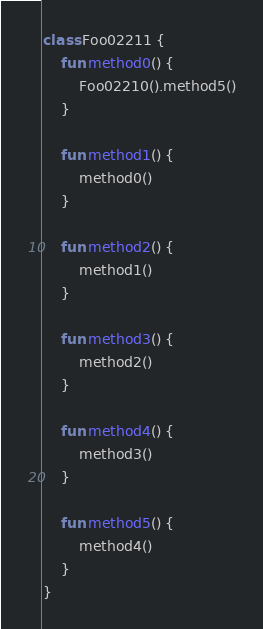Convert code to text. <code><loc_0><loc_0><loc_500><loc_500><_Kotlin_>class Foo02211 {
    fun method0() {
        Foo02210().method5()
    }

    fun method1() {
        method0()
    }

    fun method2() {
        method1()
    }

    fun method3() {
        method2()
    }

    fun method4() {
        method3()
    }

    fun method5() {
        method4()
    }
}
</code> 